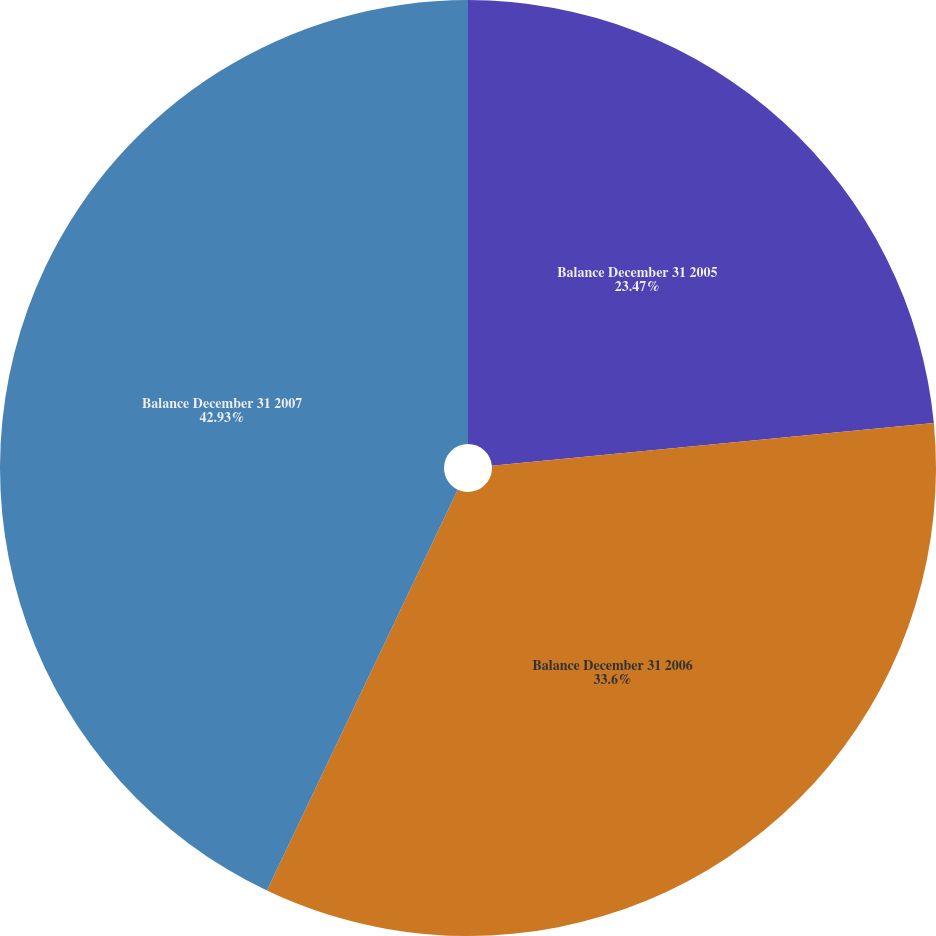Convert chart. <chart><loc_0><loc_0><loc_500><loc_500><pie_chart><fcel>Balance December 31 2005<fcel>Balance December 31 2006<fcel>Balance December 31 2007<nl><fcel>23.47%<fcel>33.6%<fcel>42.93%<nl></chart> 